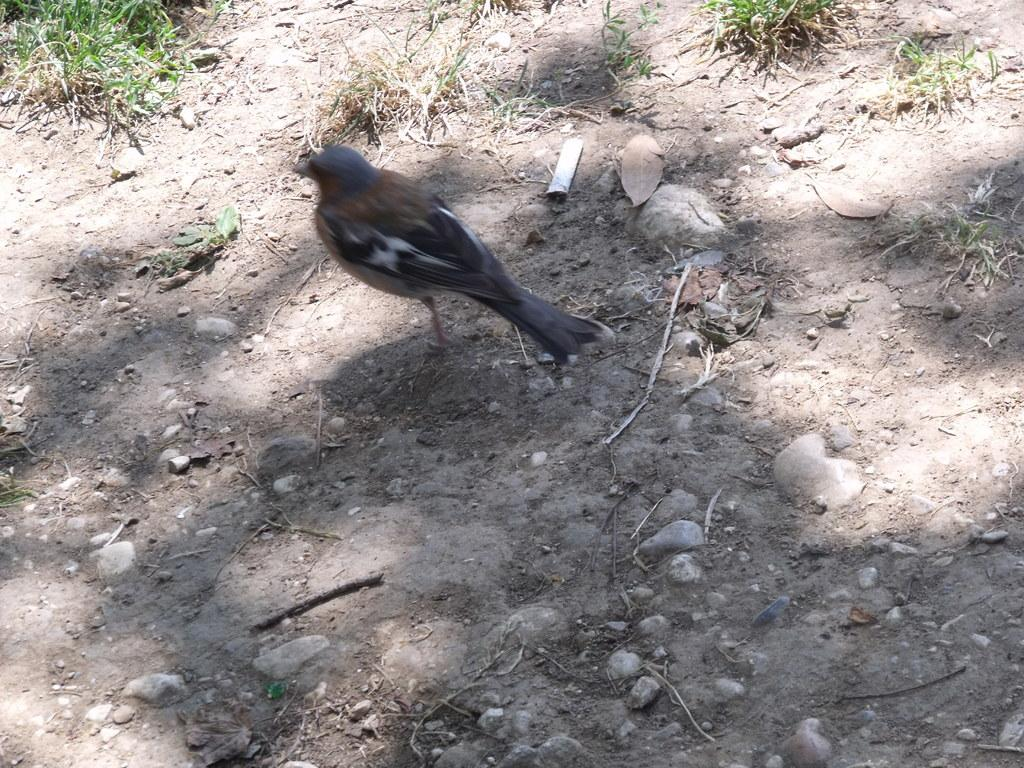What type of animal can be seen in the image? There is a bird in the image. What can be seen in the background of the image? Land, stones, grass, and dried stems are visible in the background of the image. Can you tell me how many friends the bird has in the image? There is no indication of friends in the image; it only shows a bird and the background. 